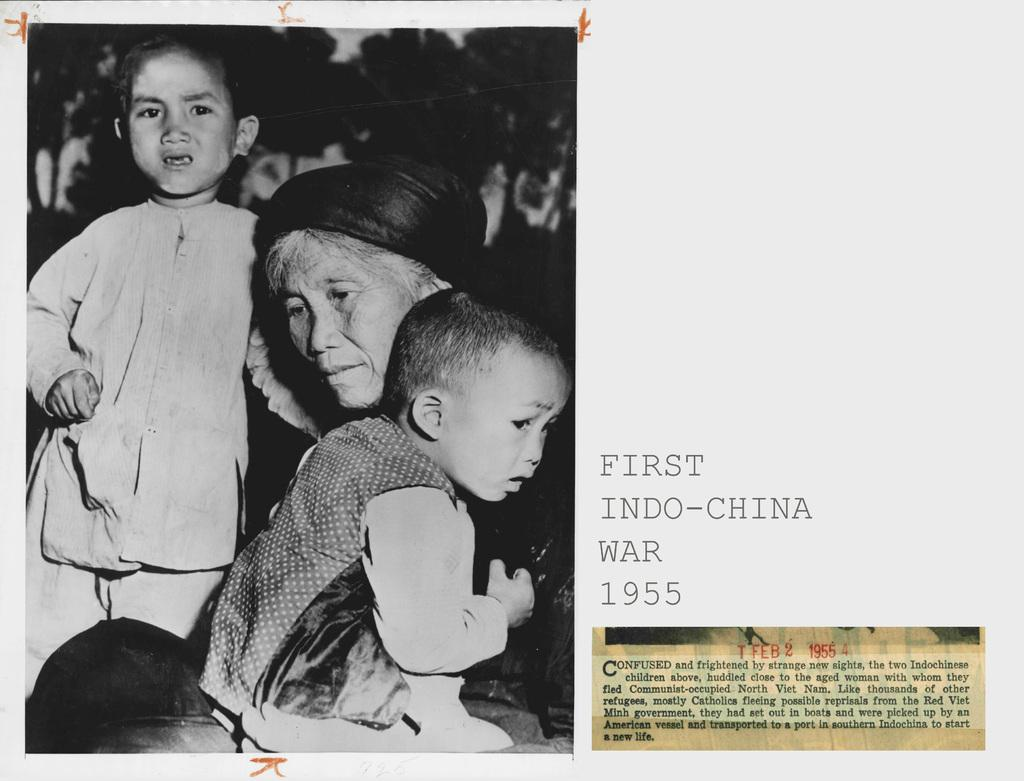What is featured on the poster in the image? There is a poster in the image, which contains a photo. How many people are in the photo on the poster? The photo includes three people. What can be seen in the background of the photo? Trees are visible in the photo. What else is present on the poster besides the photo? There is text on the poster. What time of day is it in the image, and how does it affect the pollution levels? The provided facts do not mention the time of day or any pollution levels, so it is impossible to answer this question based on the information given. 